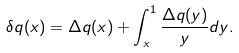Convert formula to latex. <formula><loc_0><loc_0><loc_500><loc_500>\delta q ( x ) = \Delta q ( x ) + \int _ { x } ^ { 1 } \frac { \Delta q ( y ) } { y } d y .</formula> 